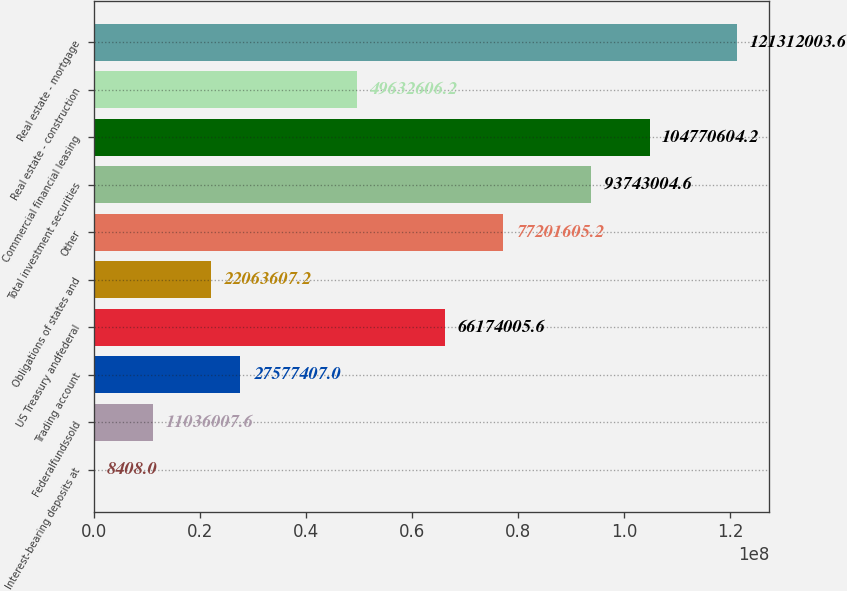Convert chart to OTSL. <chart><loc_0><loc_0><loc_500><loc_500><bar_chart><fcel>Interest-bearing deposits at<fcel>Federalfundssold<fcel>Trading account<fcel>US Treasury andfederal<fcel>Obligations of states and<fcel>Other<fcel>Total investment securities<fcel>Commercial financial leasing<fcel>Real estate - construction<fcel>Real estate - mortgage<nl><fcel>8408<fcel>1.1036e+07<fcel>2.75774e+07<fcel>6.6174e+07<fcel>2.20636e+07<fcel>7.72016e+07<fcel>9.3743e+07<fcel>1.04771e+08<fcel>4.96326e+07<fcel>1.21312e+08<nl></chart> 